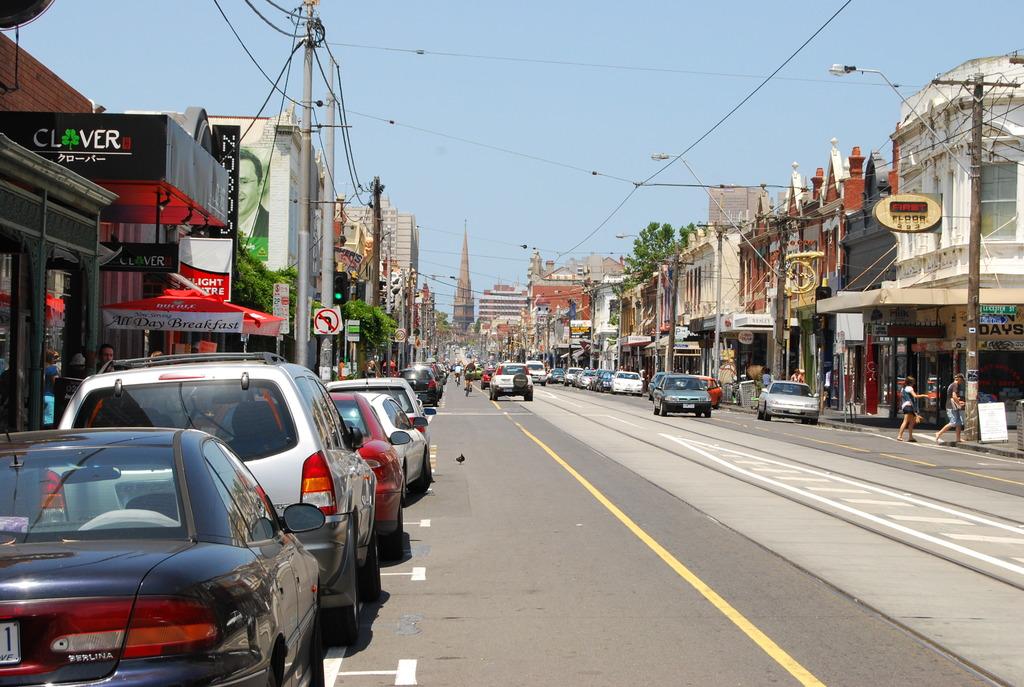What is the name on the black awning on the left?
Give a very brief answer. Clover. What kind of car is in the lower left?
Offer a terse response. Unanswerable. 